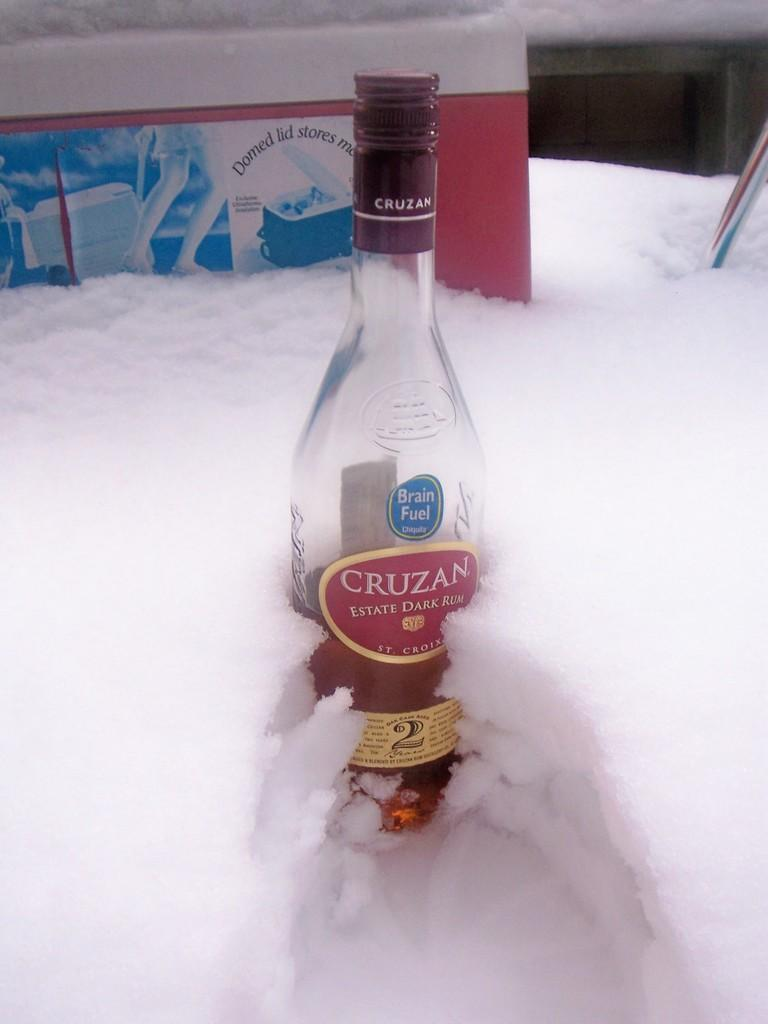<image>
Offer a succinct explanation of the picture presented. Almost empty of Cruzan sits in the white snow 